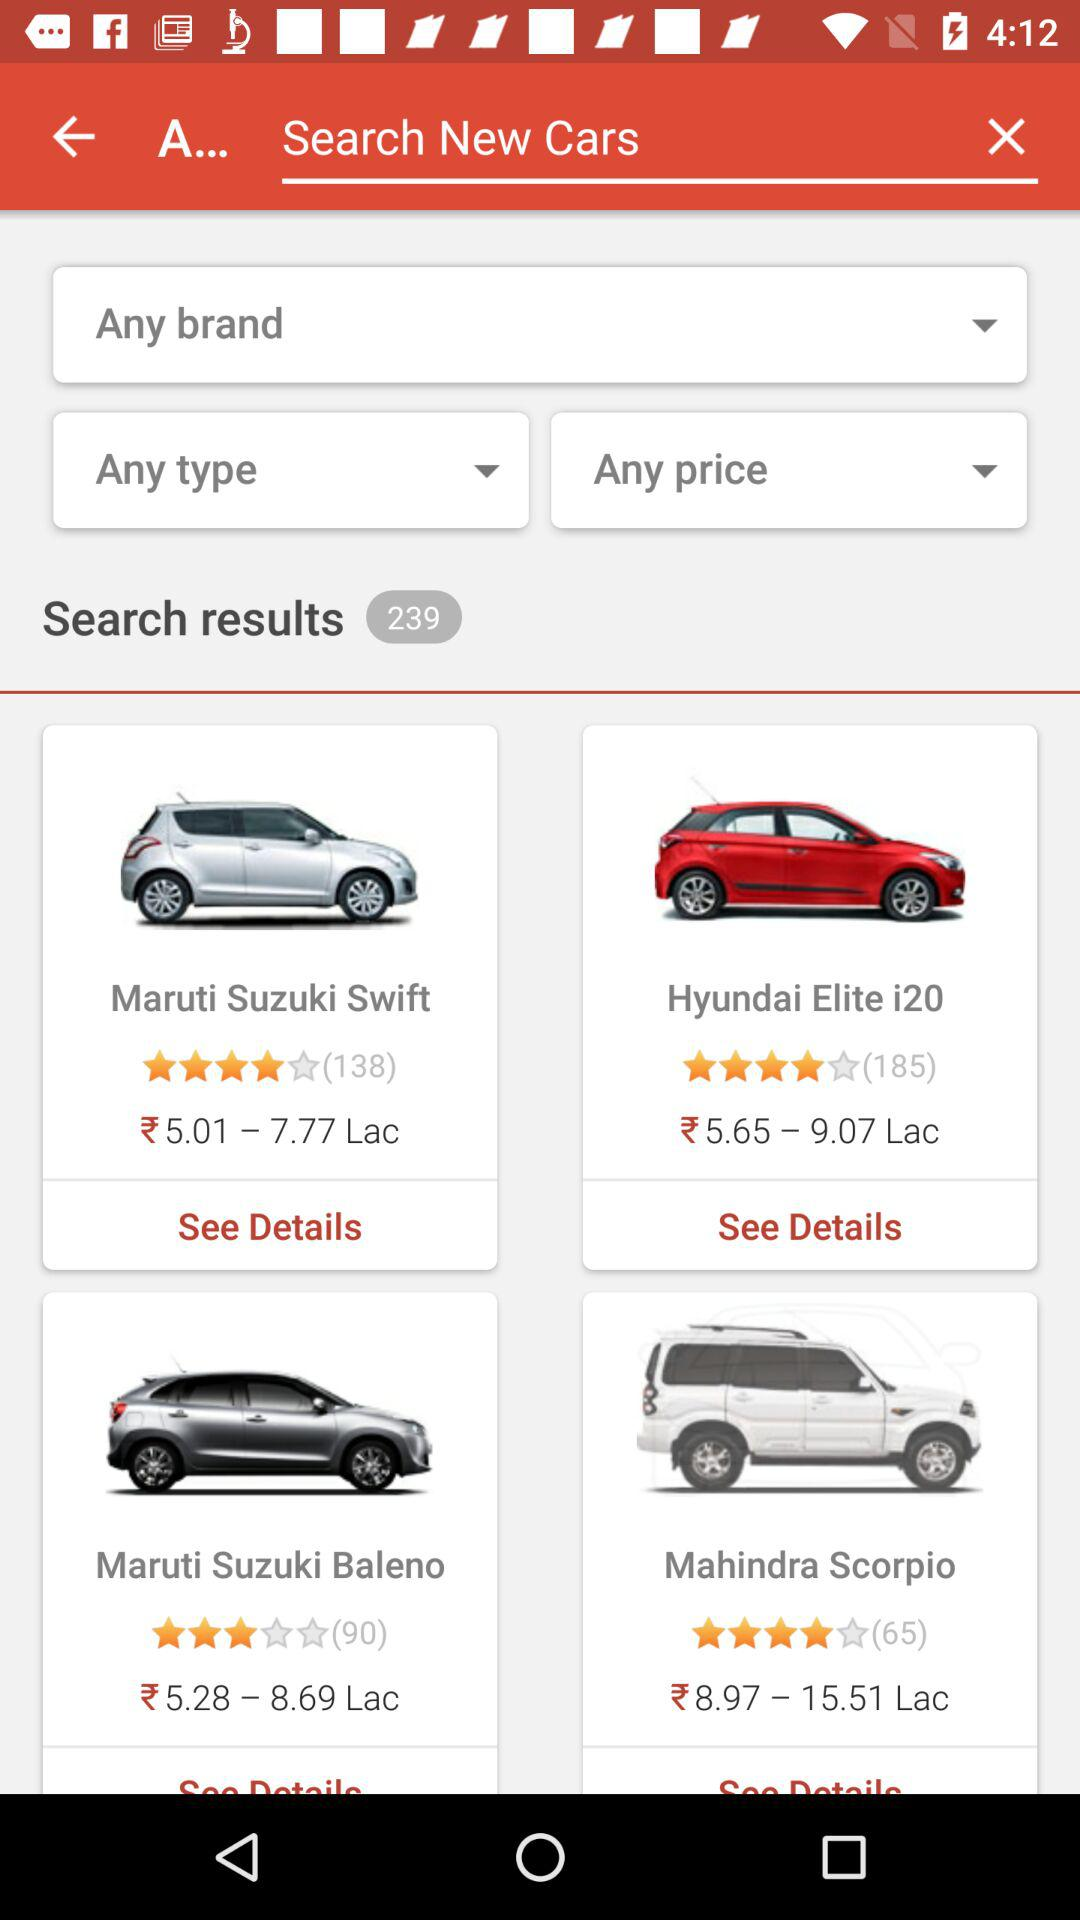What is the rating of the Mahindra Scorpio? The rating is 4 stars. 